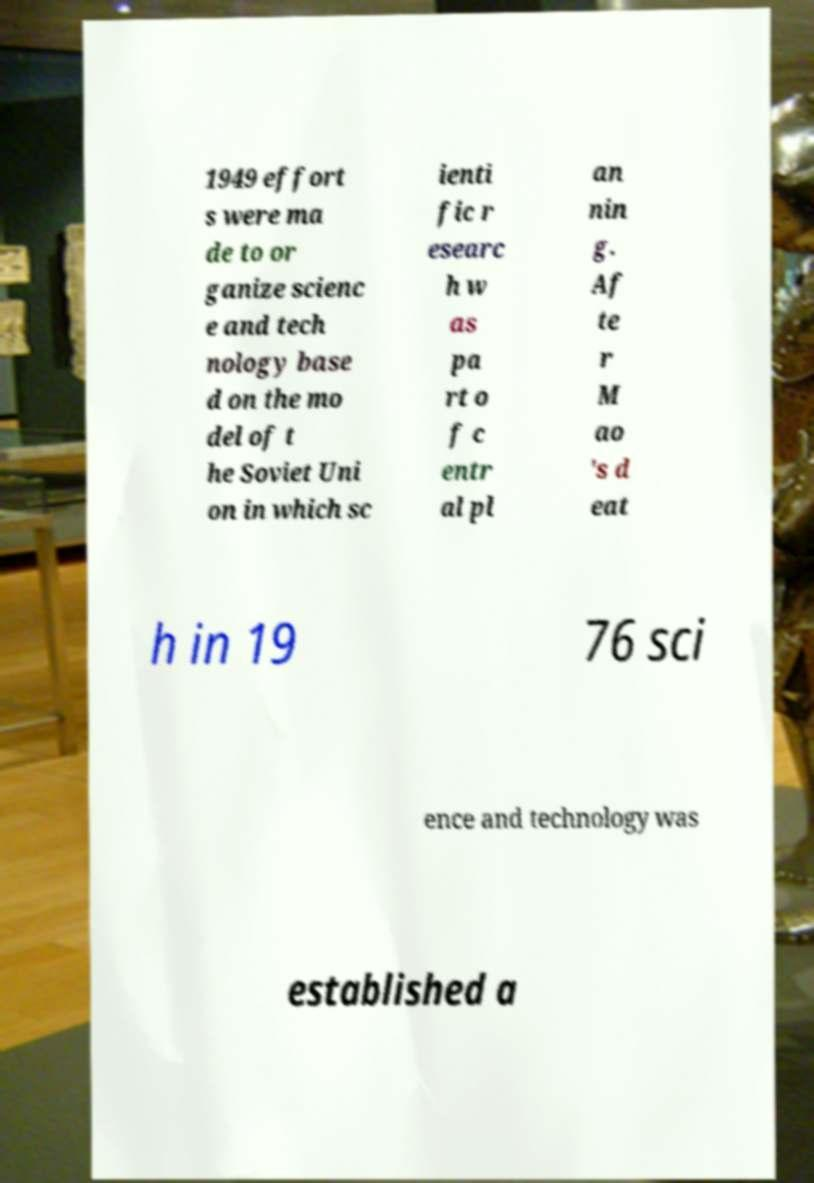I need the written content from this picture converted into text. Can you do that? 1949 effort s were ma de to or ganize scienc e and tech nology base d on the mo del of t he Soviet Uni on in which sc ienti fic r esearc h w as pa rt o f c entr al pl an nin g. Af te r M ao 's d eat h in 19 76 sci ence and technology was established a 